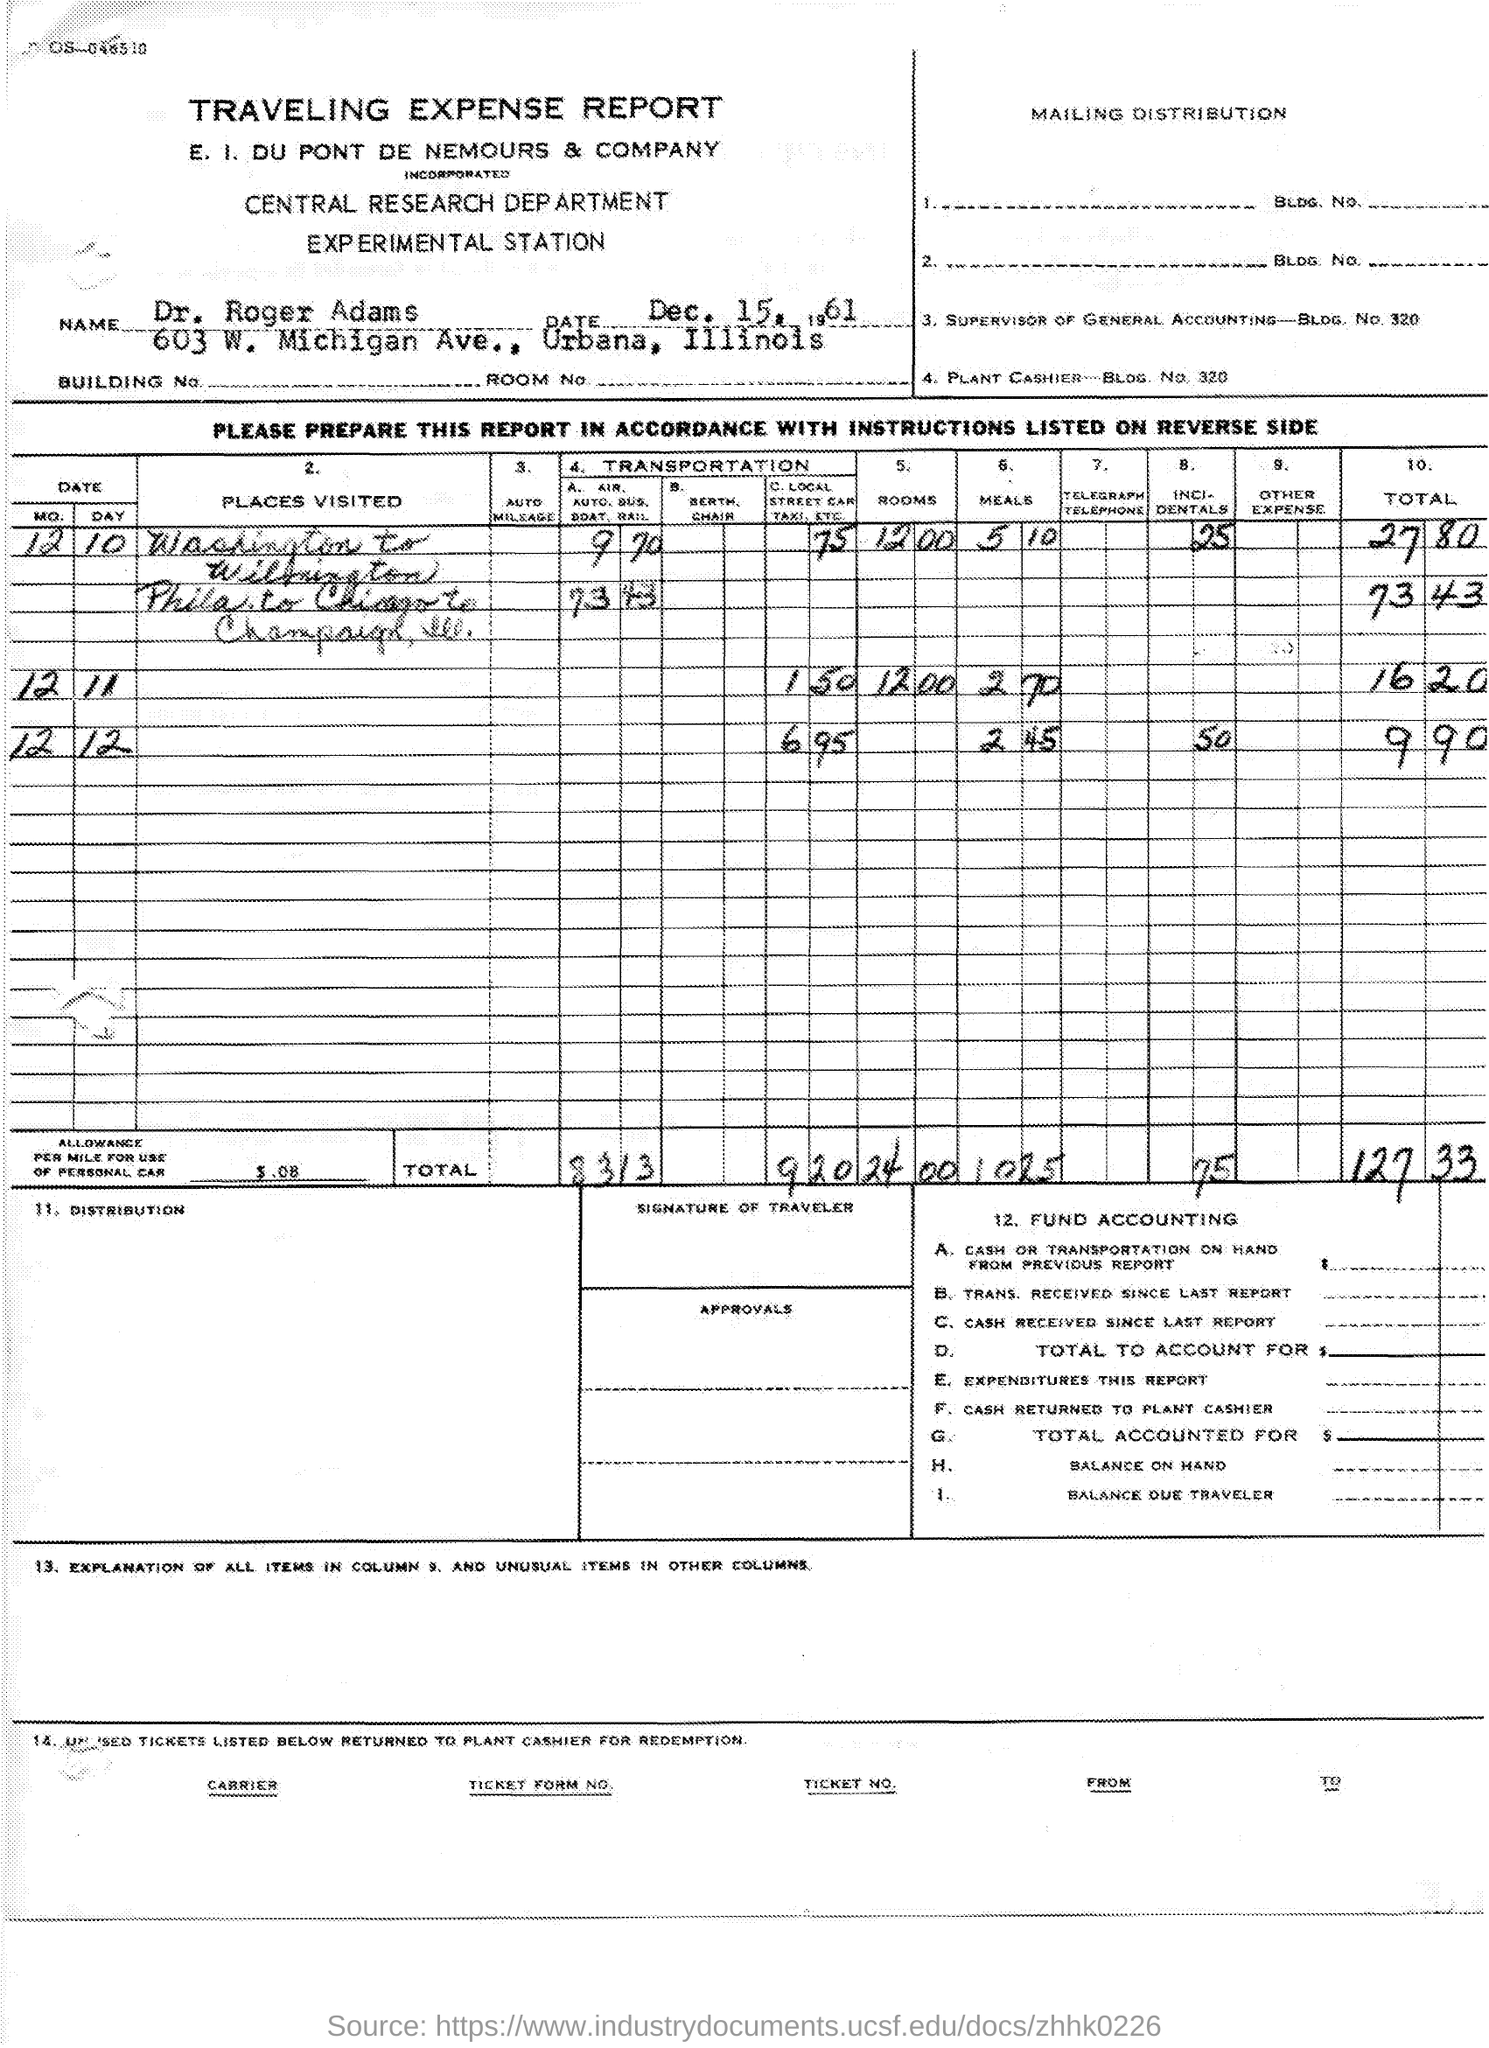Give some essential details in this illustration. The name of the report is the traveling expense report. The date mentioned in the given report is December 15, 1961. The Central Research Department is the name of the department mentioned in the given report. 